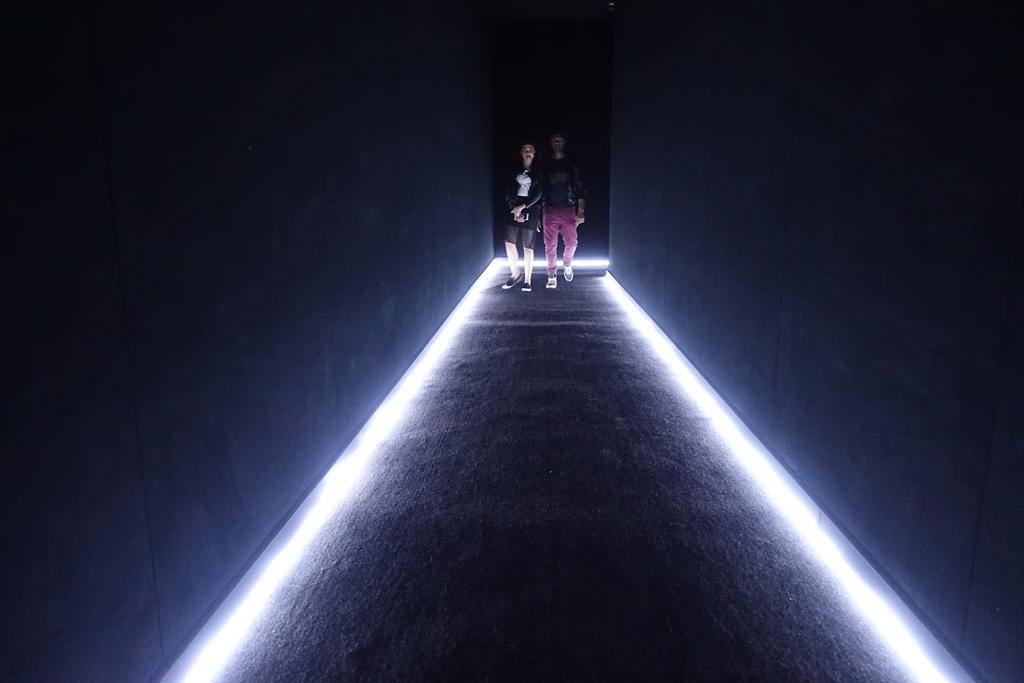Describe this image in one or two sentences. In this image I can see two people are standing. I can also see lights, walls and I can see this image is little bit in dark. 